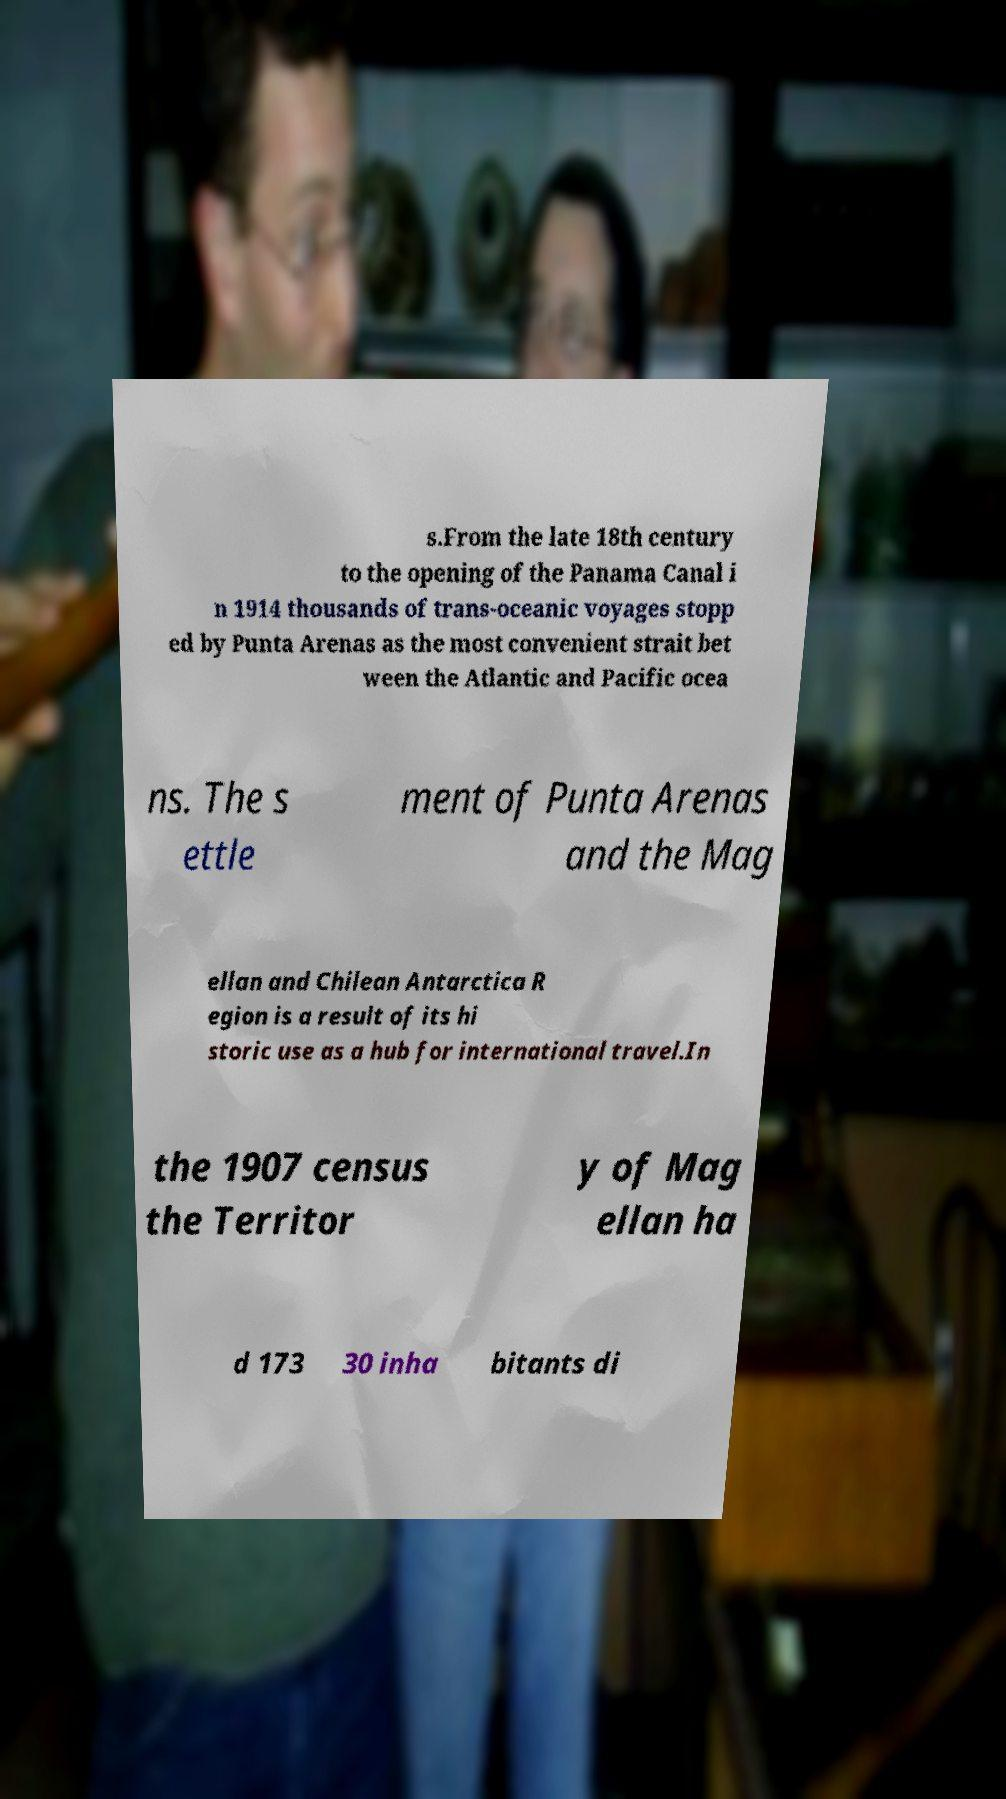Could you assist in decoding the text presented in this image and type it out clearly? s.From the late 18th century to the opening of the Panama Canal i n 1914 thousands of trans-oceanic voyages stopp ed by Punta Arenas as the most convenient strait bet ween the Atlantic and Pacific ocea ns. The s ettle ment of Punta Arenas and the Mag ellan and Chilean Antarctica R egion is a result of its hi storic use as a hub for international travel.In the 1907 census the Territor y of Mag ellan ha d 173 30 inha bitants di 